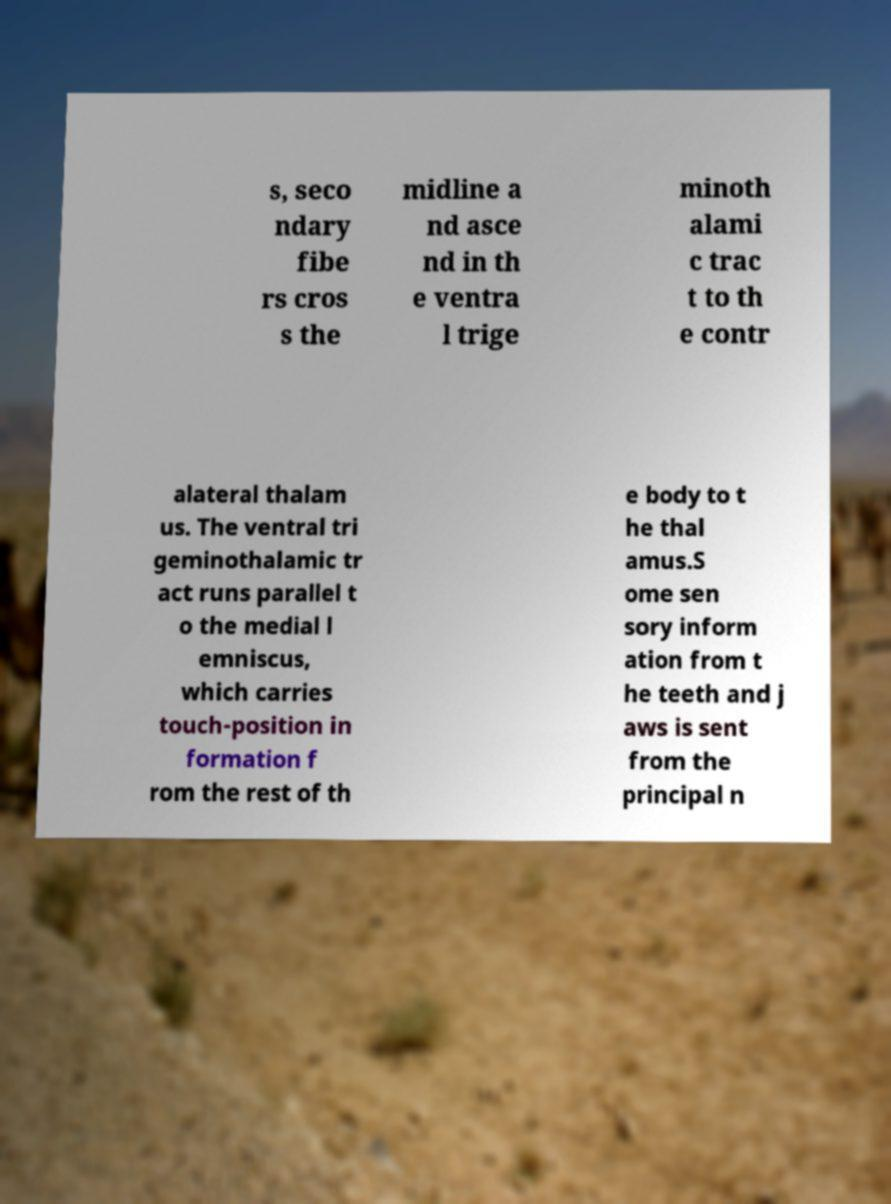Can you read and provide the text displayed in the image?This photo seems to have some interesting text. Can you extract and type it out for me? s, seco ndary fibe rs cros s the midline a nd asce nd in th e ventra l trige minoth alami c trac t to th e contr alateral thalam us. The ventral tri geminothalamic tr act runs parallel t o the medial l emniscus, which carries touch-position in formation f rom the rest of th e body to t he thal amus.S ome sen sory inform ation from t he teeth and j aws is sent from the principal n 